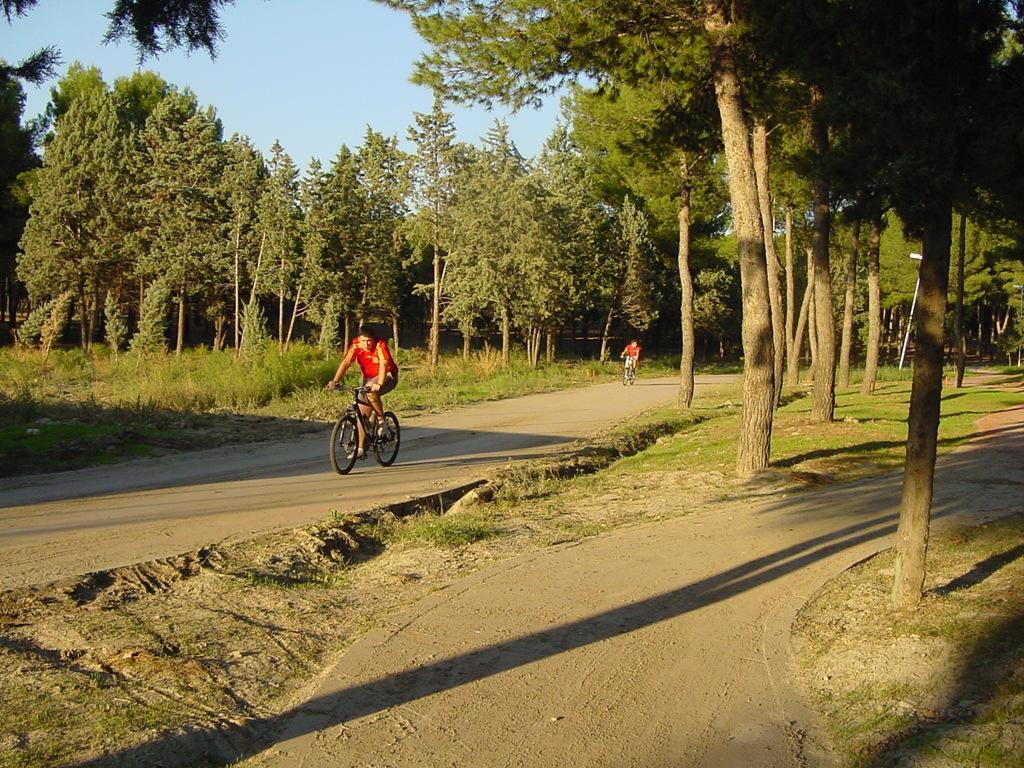In one or two sentences, can you explain what this image depicts? In this image I can see there are two persons riding on bi-cycle on the road in the middle and I can see trees and the sky and grass visible in the middle. 